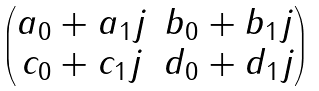<formula> <loc_0><loc_0><loc_500><loc_500>\begin{pmatrix} a _ { 0 } + a _ { 1 } j & b _ { 0 } + b _ { 1 } j \\ c _ { 0 } + c _ { 1 } j & d _ { 0 } + d _ { 1 } j \end{pmatrix}</formula> 